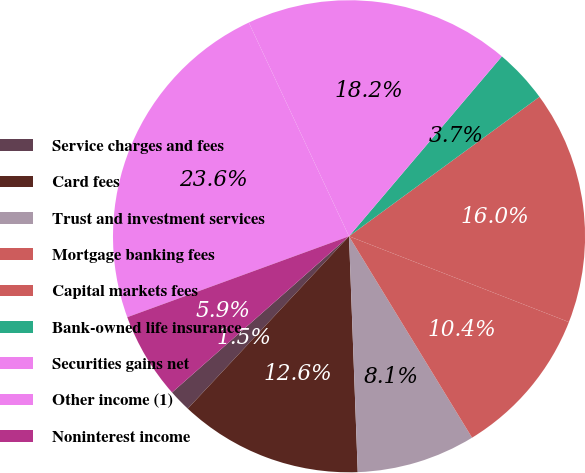Convert chart to OTSL. <chart><loc_0><loc_0><loc_500><loc_500><pie_chart><fcel>Service charges and fees<fcel>Card fees<fcel>Trust and investment services<fcel>Mortgage banking fees<fcel>Capital markets fees<fcel>Bank-owned life insurance<fcel>Securities gains net<fcel>Other income (1)<fcel>Noninterest income<nl><fcel>1.52%<fcel>12.56%<fcel>8.14%<fcel>10.35%<fcel>15.98%<fcel>3.73%<fcel>18.19%<fcel>23.59%<fcel>5.94%<nl></chart> 